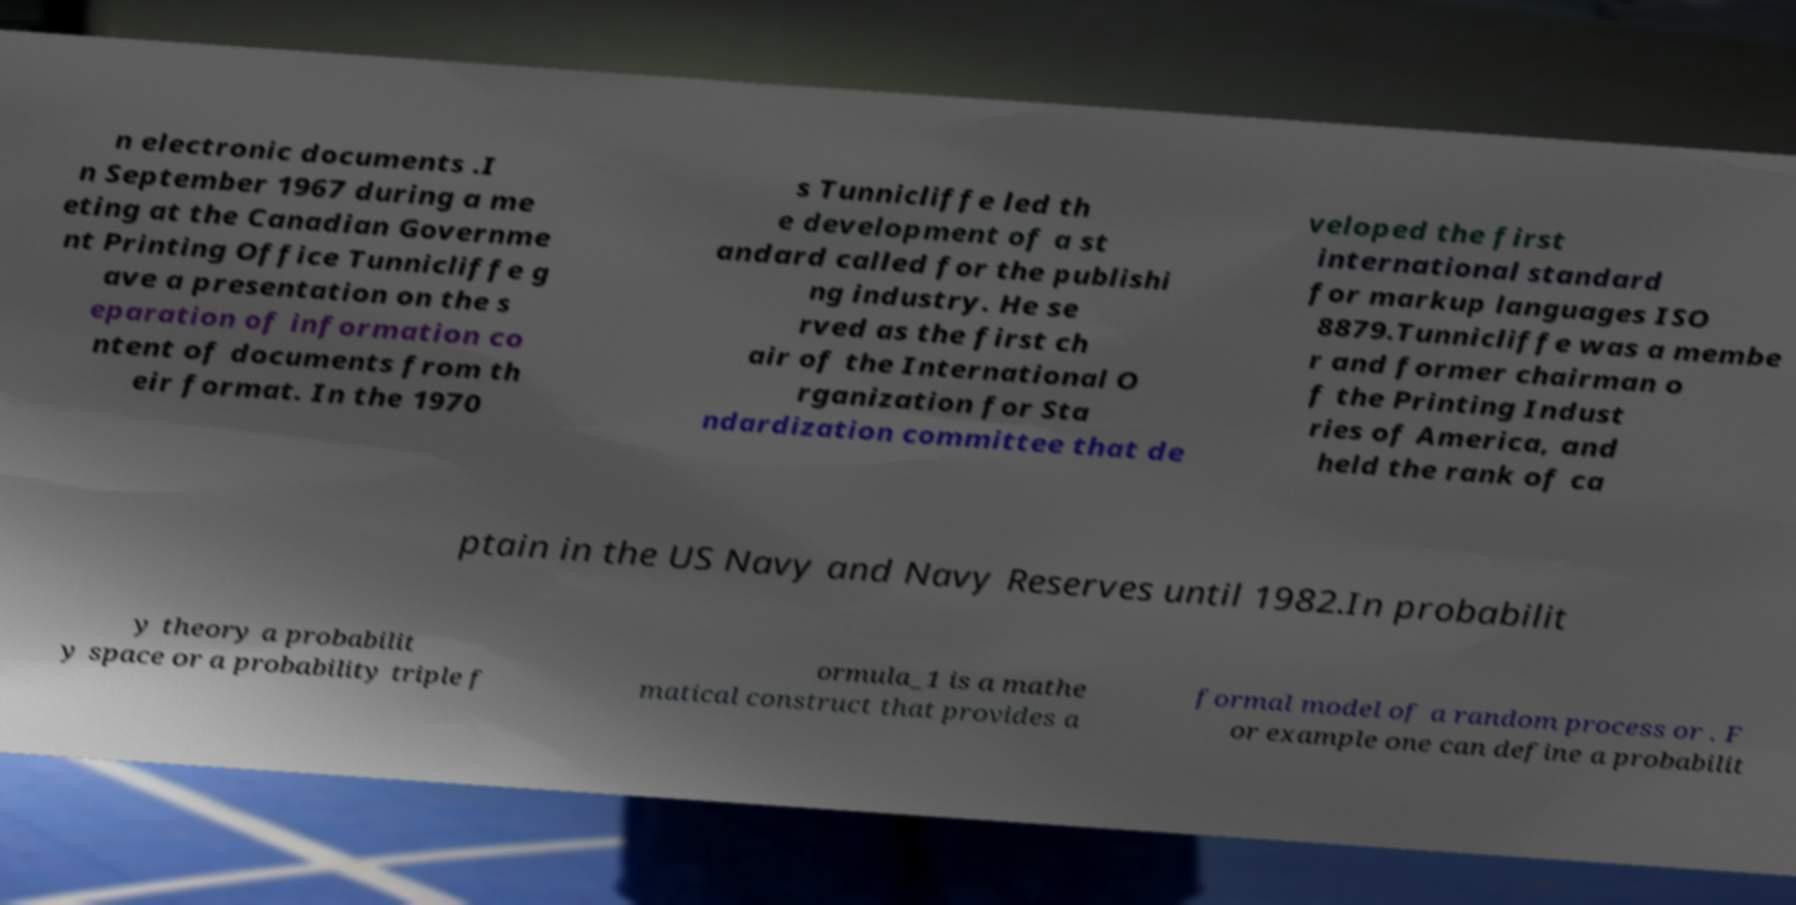Please read and relay the text visible in this image. What does it say? n electronic documents .I n September 1967 during a me eting at the Canadian Governme nt Printing Office Tunnicliffe g ave a presentation on the s eparation of information co ntent of documents from th eir format. In the 1970 s Tunnicliffe led th e development of a st andard called for the publishi ng industry. He se rved as the first ch air of the International O rganization for Sta ndardization committee that de veloped the first international standard for markup languages ISO 8879.Tunnicliffe was a membe r and former chairman o f the Printing Indust ries of America, and held the rank of ca ptain in the US Navy and Navy Reserves until 1982.In probabilit y theory a probabilit y space or a probability triple f ormula_1 is a mathe matical construct that provides a formal model of a random process or . F or example one can define a probabilit 